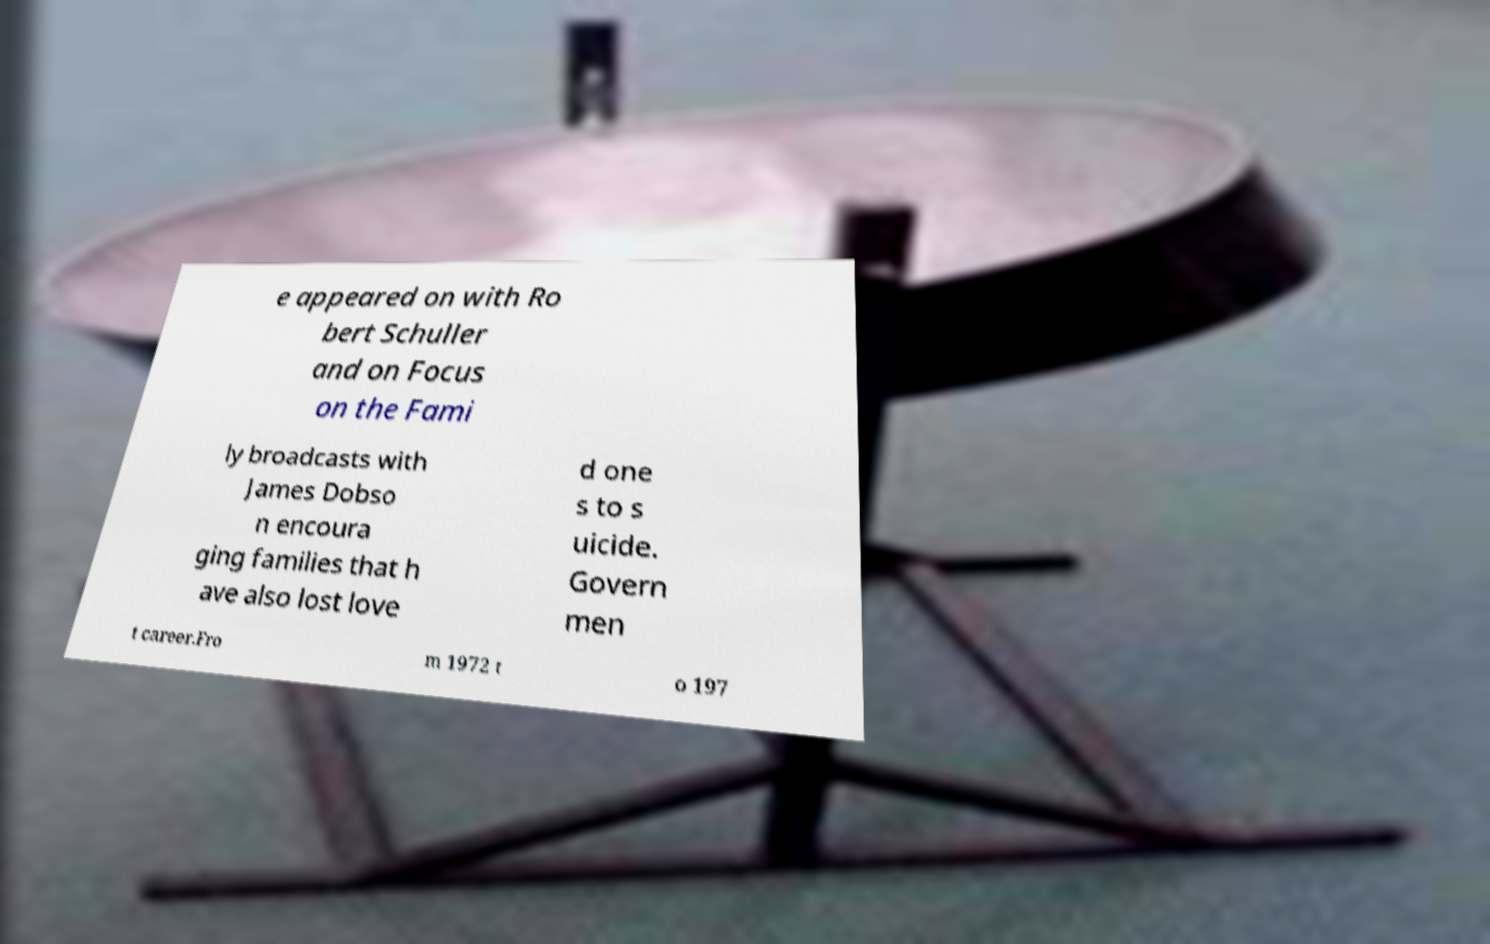Can you read and provide the text displayed in the image?This photo seems to have some interesting text. Can you extract and type it out for me? e appeared on with Ro bert Schuller and on Focus on the Fami ly broadcasts with James Dobso n encoura ging families that h ave also lost love d one s to s uicide. Govern men t career.Fro m 1972 t o 197 